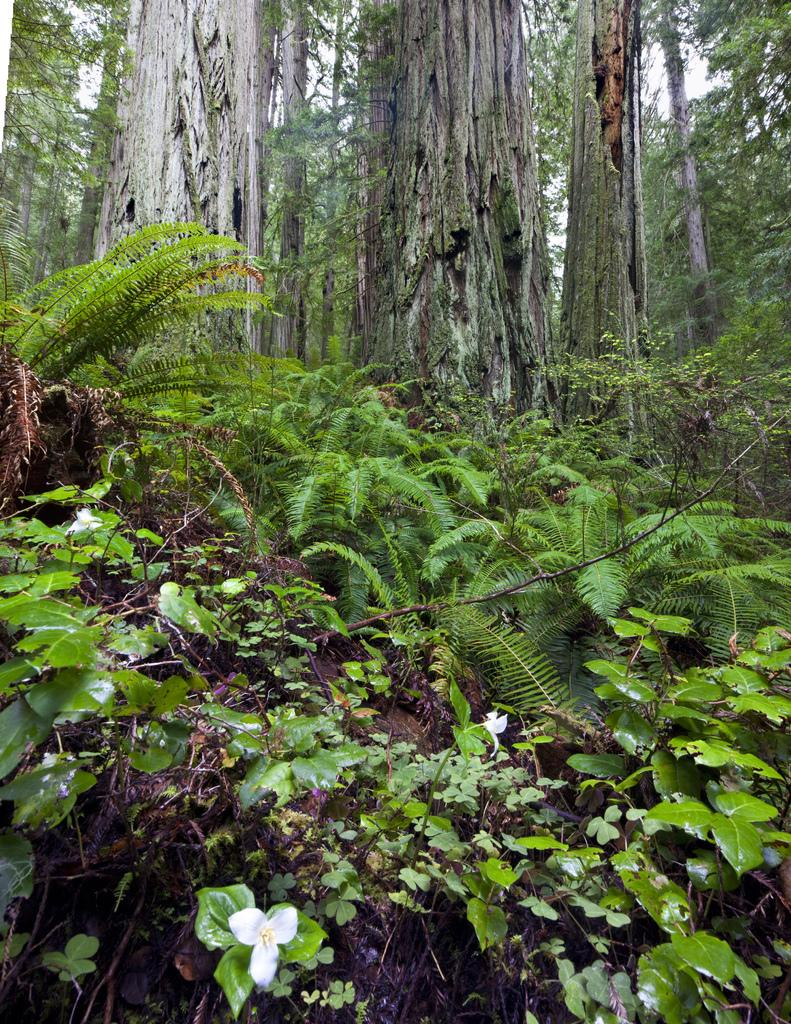What type of vegetation is in the front of the image? There are plants in the front of the image. Can you describe the flower at the bottom of the image? There is a white color flower at the bottom of the image. What can be seen in the background of the image? There are trees and the sky visible in the background of the image. Where is the frog sitting in the image? There is no frog present in the image. What type of lipstick is the person wearing in the image? There is no person or lipstick present in the image. 